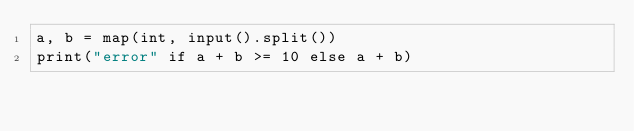Convert code to text. <code><loc_0><loc_0><loc_500><loc_500><_Python_>a, b = map(int, input().split())
print("error" if a + b >= 10 else a + b)</code> 